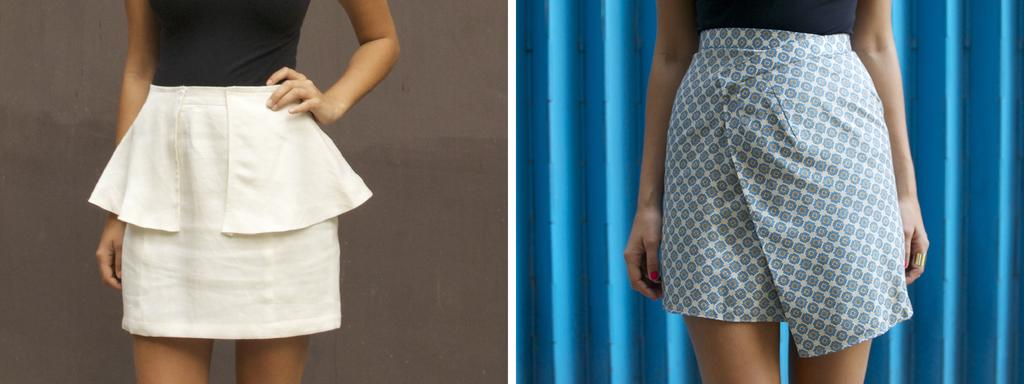What type of artwork is featured in the image? The image contains a collage. What are the persons in the collage wearing? The persons in the collage are wearing skirts and tops. What can be seen in the background of the collage? There is a wall in the background of the collage. Who is the owner of the trouble in the image? There is no reference to any trouble or ownership in the image; it features a collage with persons wearing skirts and tops in front of a wall. 